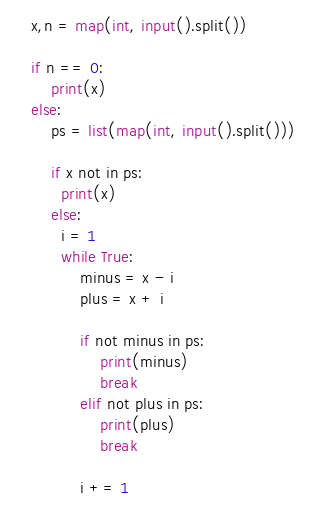<code> <loc_0><loc_0><loc_500><loc_500><_Python_>x,n = map(int, input().split())

if n == 0:
    print(x)
else:
    ps = list(map(int, input().split()))
    
    if x not in ps:
      print(x)
    else:
      i = 1
      while True:
          minus = x - i
          plus = x + i

          if not minus in ps:
              print(minus)
              break
          elif not plus in ps:
              print(plus)
              break

          i += 1</code> 